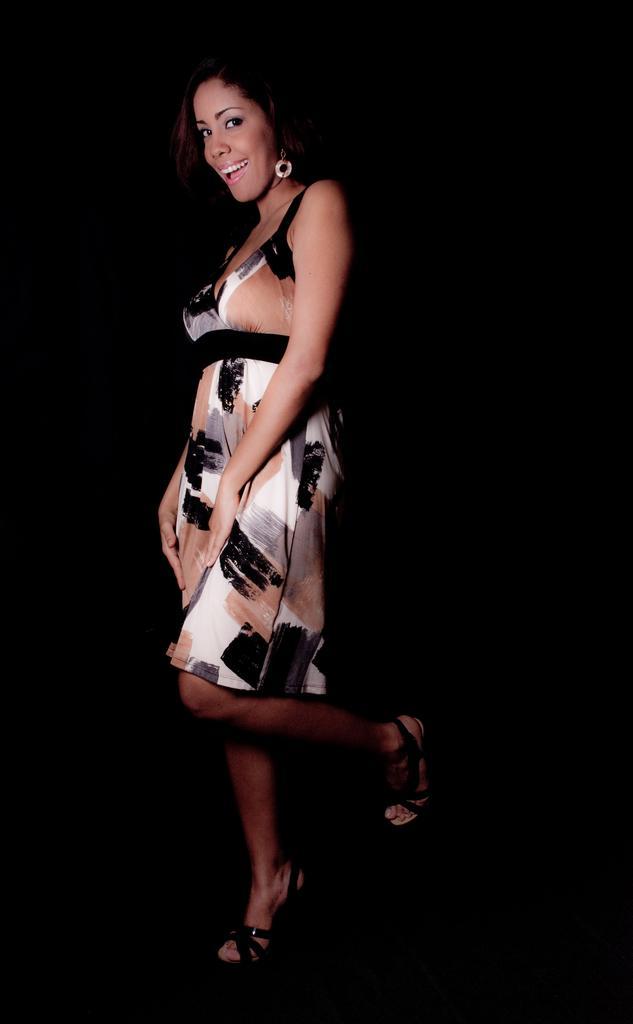Please provide a concise description of this image. In the center of the image there is a lady. The background of the image is black in color. 